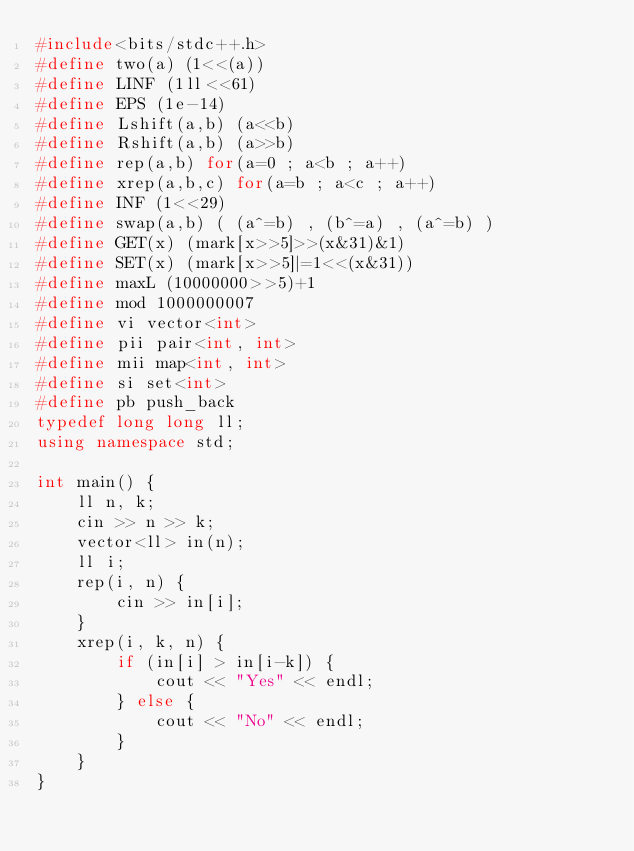Convert code to text. <code><loc_0><loc_0><loc_500><loc_500><_C++_>#include<bits/stdc++.h>
#define two(a) (1<<(a))
#define LINF (1ll<<61)
#define EPS (1e-14)
#define Lshift(a,b) (a<<b)
#define Rshift(a,b) (a>>b)
#define rep(a,b) for(a=0 ; a<b ; a++)
#define xrep(a,b,c) for(a=b ; a<c ; a++)
#define INF (1<<29)
#define swap(a,b) ( (a^=b) , (b^=a) , (a^=b) )
#define GET(x) (mark[x>>5]>>(x&31)&1)
#define SET(x) (mark[x>>5]|=1<<(x&31))
#define maxL (10000000>>5)+1
#define mod 1000000007
#define vi vector<int>
#define pii pair<int, int>
#define mii map<int, int>
#define si set<int>
#define pb push_back
typedef long long ll;
using namespace std;

int main() {
    ll n, k;
    cin >> n >> k;
    vector<ll> in(n);
    ll i;
    rep(i, n) {
        cin >> in[i];
    }
    xrep(i, k, n) {
        if (in[i] > in[i-k]) {
            cout << "Yes" << endl;
        } else {
            cout << "No" << endl;
        }
    }
}
</code> 